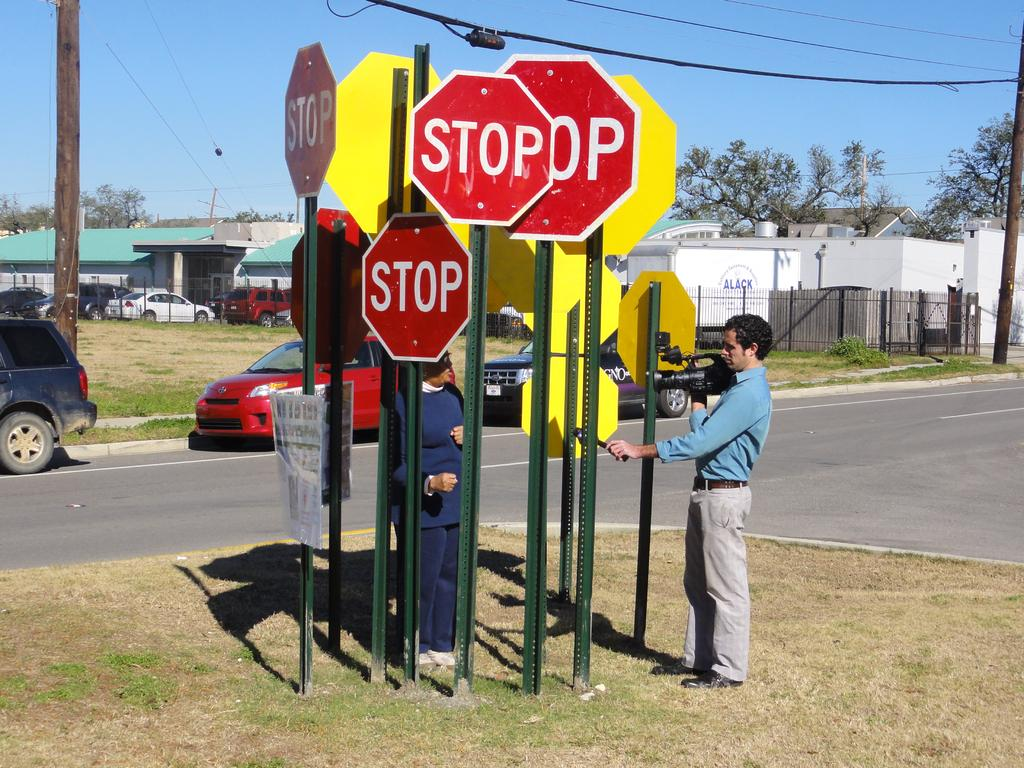Provide a one-sentence caption for the provided image. Several red stop signs clustered together at the street. 